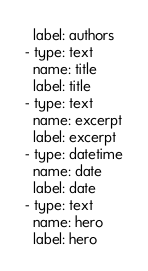Convert code to text. <code><loc_0><loc_0><loc_500><loc_500><_YAML_>  label: authors
- type: text
  name: title
  label: title
- type: text
  name: excerpt
  label: excerpt
- type: datetime
  name: date
  label: date
- type: text
  name: hero
  label: hero
</code> 